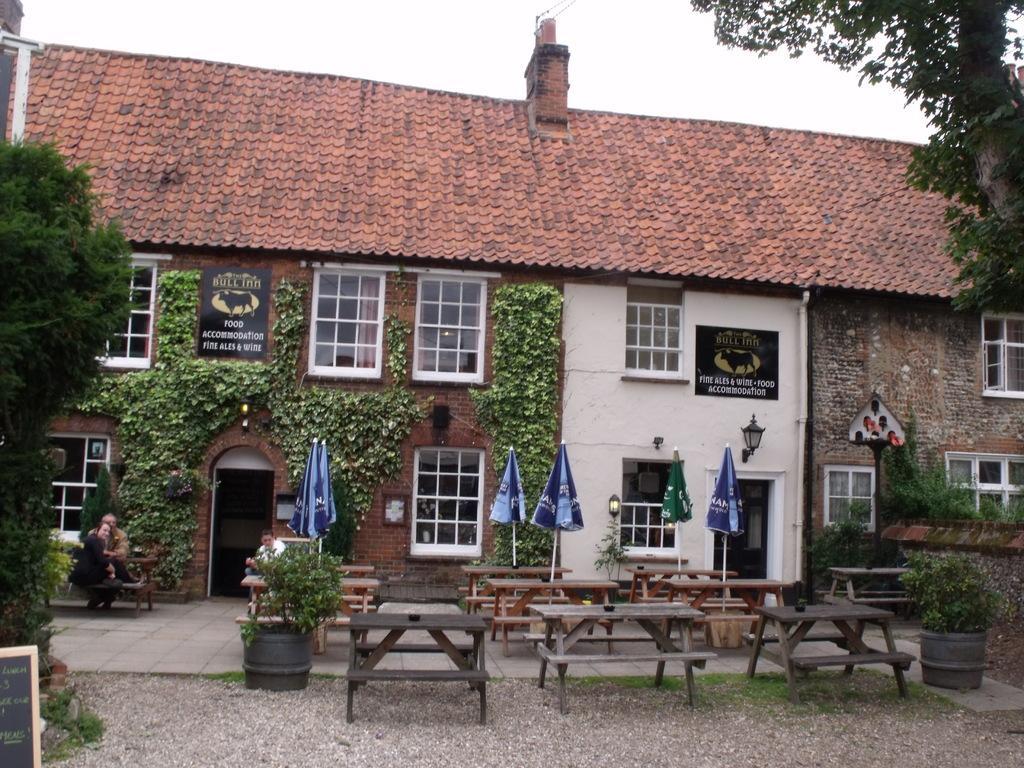Could you give a brief overview of what you see in this image? In this image we can see buildings, persons sitting on the benches, house plants, parasols, street lights, name boards, trees, cables and sky. 